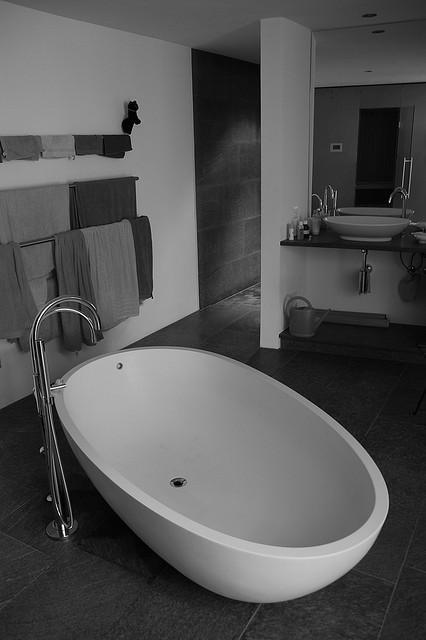How many people are sitting down?
Give a very brief answer. 0. 